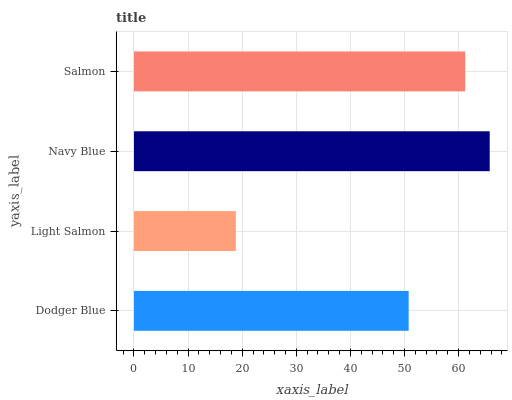Is Light Salmon the minimum?
Answer yes or no. Yes. Is Navy Blue the maximum?
Answer yes or no. Yes. Is Navy Blue the minimum?
Answer yes or no. No. Is Light Salmon the maximum?
Answer yes or no. No. Is Navy Blue greater than Light Salmon?
Answer yes or no. Yes. Is Light Salmon less than Navy Blue?
Answer yes or no. Yes. Is Light Salmon greater than Navy Blue?
Answer yes or no. No. Is Navy Blue less than Light Salmon?
Answer yes or no. No. Is Salmon the high median?
Answer yes or no. Yes. Is Dodger Blue the low median?
Answer yes or no. Yes. Is Navy Blue the high median?
Answer yes or no. No. Is Light Salmon the low median?
Answer yes or no. No. 